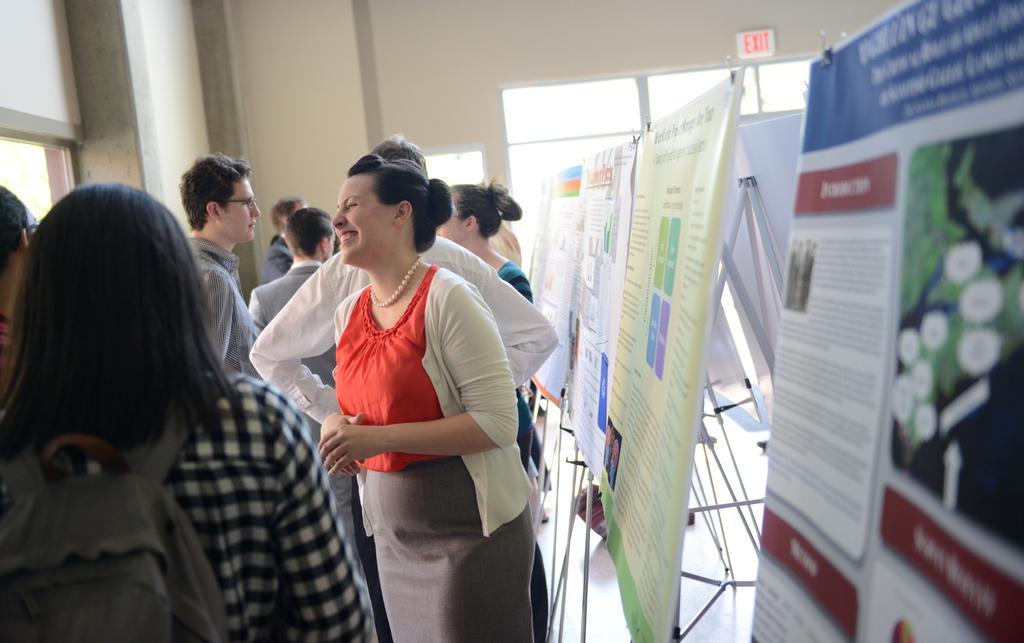Could you give a brief overview of what you see in this image? In this image, we can see a group of people and banner stands on the floor. In the middle of the image, we can see a woman smiling. On the left side of the image, we can see a person wearing a backpack. In the background, we can see the wall, sign board and glass objects. 